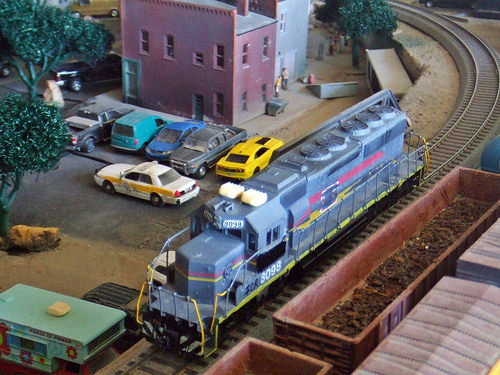<image>
Is the car to the right of the truck? No. The car is not to the right of the truck. The horizontal positioning shows a different relationship. 